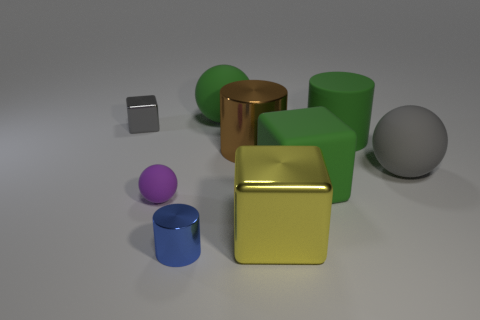Is the matte cylinder the same color as the rubber block?
Offer a very short reply. Yes. How many large things are the same color as the tiny cube?
Give a very brief answer. 1. What material is the green thing that is in front of the gray shiny cube and behind the big gray matte ball?
Your response must be concise. Rubber. There is a large sphere on the right side of the large green cylinder; is it the same color as the tiny object that is behind the big gray matte thing?
Give a very brief answer. Yes. How many red things are either large cylinders or large matte things?
Provide a succinct answer. 0. Is the number of gray spheres that are behind the yellow cube less than the number of big green balls that are to the right of the rubber block?
Your answer should be compact. No. Is there a matte cube of the same size as the green cylinder?
Your response must be concise. Yes. There is a object that is left of the purple thing; is its size the same as the yellow object?
Make the answer very short. No. Is the number of purple matte balls greater than the number of small yellow metallic cubes?
Keep it short and to the point. Yes. Are there any gray metal things of the same shape as the blue metal thing?
Ensure brevity in your answer.  No. 